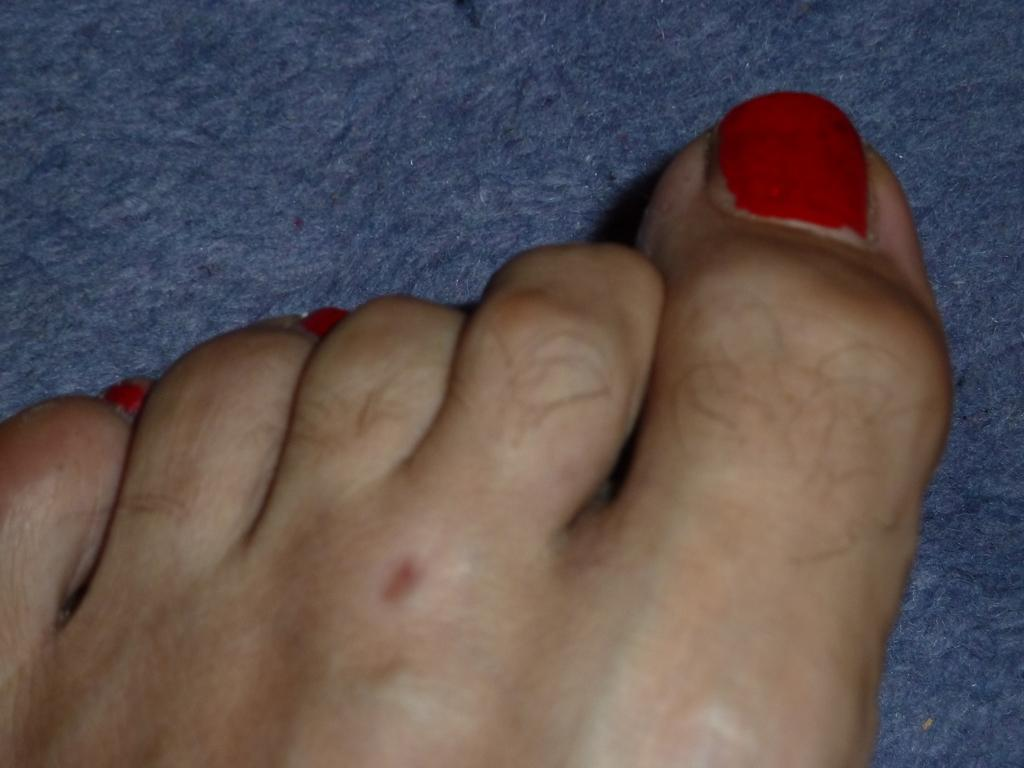What part of a person's body is visible in the image? There is a person's leg in the image. What is located at the bottom of the image? There is a mat at the bottom of the image. How many babies are present in the image? There is no indication of any babies in the image. What type of trade is being conducted in the image? There is no trade being conducted in the image. 